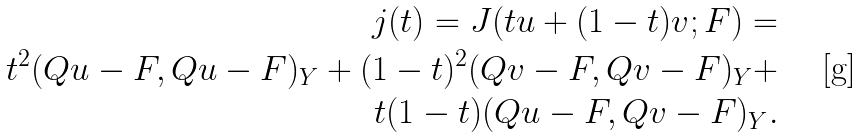<formula> <loc_0><loc_0><loc_500><loc_500>j ( t ) = J ( t u + ( 1 - t ) v ; F ) = \\ t ^ { 2 } ( Q u - F , Q u - F ) _ { Y } + ( 1 - t ) ^ { 2 } ( Q v - F , Q v - F ) _ { Y } + \\ t ( 1 - t ) ( Q u - F , Q v - F ) _ { Y } .</formula> 